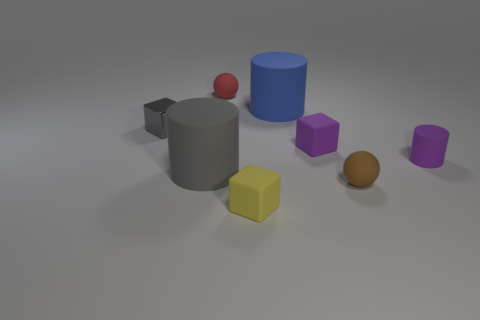Does the gray block have the same size as the rubber sphere in front of the tiny red ball?
Your answer should be compact. Yes. How big is the blue matte object?
Ensure brevity in your answer.  Large. The other tiny block that is made of the same material as the small purple block is what color?
Make the answer very short. Yellow. What number of big blue cylinders have the same material as the red sphere?
Provide a short and direct response. 1. What number of things are big brown metal objects or gray cubes behind the gray rubber object?
Ensure brevity in your answer.  1. Are the big thing that is behind the shiny cube and the gray cylinder made of the same material?
Provide a short and direct response. Yes. The metal block that is the same size as the brown matte thing is what color?
Provide a succinct answer. Gray. Are there any tiny purple objects that have the same shape as the big gray matte thing?
Your answer should be very brief. Yes. There is a rubber cube behind the ball in front of the big cylinder behind the purple matte cylinder; what is its color?
Ensure brevity in your answer.  Purple. How many metallic things are either green cylinders or cylinders?
Offer a terse response. 0. 